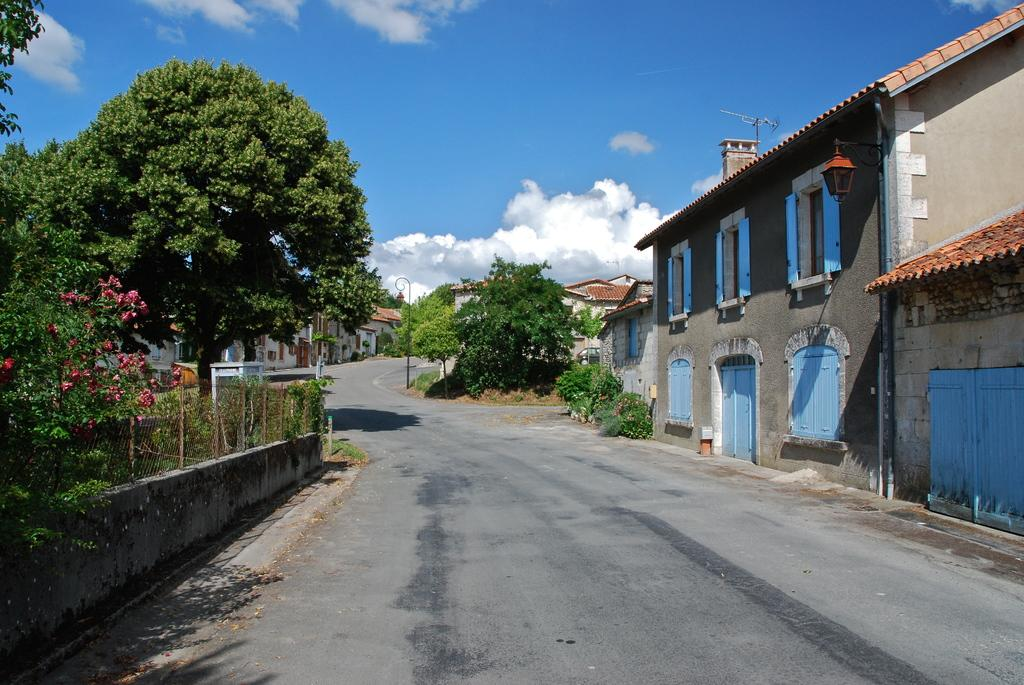What type of structures are visible in the image? There are buildings with windows and roof in the image. What can be seen on the ground in the image? There is a pathway in the image. What type of vegetation is present in the image? There are plants and a group of trees in the image. What additional features can be seen in the image? There are flowers, poles, and a metal fence in the image. What is visible in the sky in the image? The sky is visible in the image and appears cloudy. Can you see a nest in the image? There is no nest present in the image. What type of lamp is being used by the flowers in the image? There are no lamps present in the image, and the flowers are not using any lamps. 